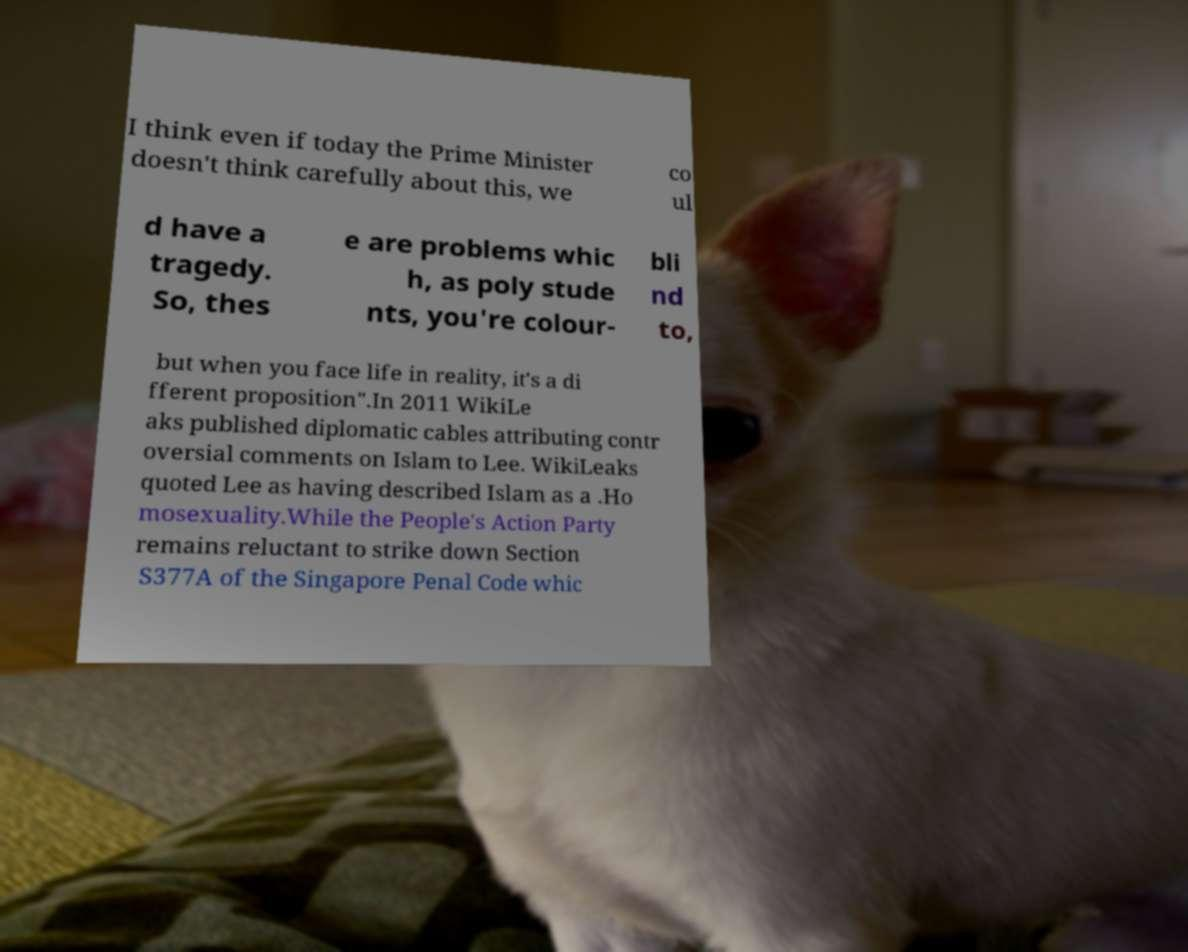Please identify and transcribe the text found in this image. I think even if today the Prime Minister doesn't think carefully about this, we co ul d have a tragedy. So, thes e are problems whic h, as poly stude nts, you're colour- bli nd to, but when you face life in reality, it's a di fferent proposition".In 2011 WikiLe aks published diplomatic cables attributing contr oversial comments on Islam to Lee. WikiLeaks quoted Lee as having described Islam as a .Ho mosexuality.While the People's Action Party remains reluctant to strike down Section S377A of the Singapore Penal Code whic 